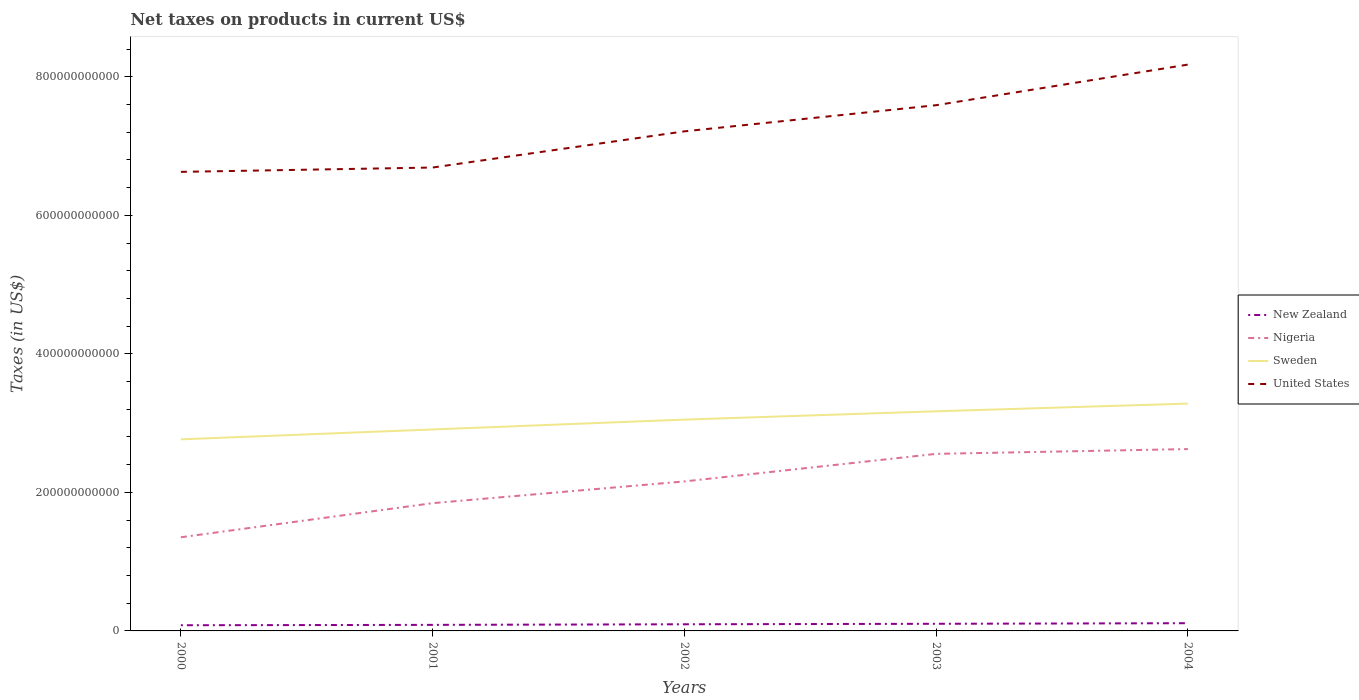Across all years, what is the maximum net taxes on products in New Zealand?
Provide a short and direct response. 8.20e+09. What is the total net taxes on products in Nigeria in the graph?
Ensure brevity in your answer.  -4.92e+1. What is the difference between the highest and the second highest net taxes on products in Nigeria?
Provide a succinct answer. 1.27e+11. What is the difference between the highest and the lowest net taxes on products in United States?
Offer a terse response. 2. How many years are there in the graph?
Provide a succinct answer. 5. What is the difference between two consecutive major ticks on the Y-axis?
Offer a terse response. 2.00e+11. Are the values on the major ticks of Y-axis written in scientific E-notation?
Your answer should be compact. No. Does the graph contain any zero values?
Provide a short and direct response. No. Does the graph contain grids?
Ensure brevity in your answer.  No. How are the legend labels stacked?
Provide a short and direct response. Vertical. What is the title of the graph?
Your answer should be very brief. Net taxes on products in current US$. Does "Andorra" appear as one of the legend labels in the graph?
Your answer should be compact. No. What is the label or title of the X-axis?
Give a very brief answer. Years. What is the label or title of the Y-axis?
Provide a succinct answer. Taxes (in US$). What is the Taxes (in US$) in New Zealand in 2000?
Offer a very short reply. 8.20e+09. What is the Taxes (in US$) of Nigeria in 2000?
Give a very brief answer. 1.35e+11. What is the Taxes (in US$) of Sweden in 2000?
Provide a short and direct response. 2.77e+11. What is the Taxes (in US$) in United States in 2000?
Provide a short and direct response. 6.63e+11. What is the Taxes (in US$) of New Zealand in 2001?
Keep it short and to the point. 8.74e+09. What is the Taxes (in US$) in Nigeria in 2001?
Provide a succinct answer. 1.84e+11. What is the Taxes (in US$) of Sweden in 2001?
Give a very brief answer. 2.91e+11. What is the Taxes (in US$) of United States in 2001?
Give a very brief answer. 6.69e+11. What is the Taxes (in US$) in New Zealand in 2002?
Your response must be concise. 9.59e+09. What is the Taxes (in US$) in Nigeria in 2002?
Offer a very short reply. 2.16e+11. What is the Taxes (in US$) of Sweden in 2002?
Keep it short and to the point. 3.05e+11. What is the Taxes (in US$) of United States in 2002?
Provide a succinct answer. 7.21e+11. What is the Taxes (in US$) of New Zealand in 2003?
Give a very brief answer. 1.03e+1. What is the Taxes (in US$) in Nigeria in 2003?
Make the answer very short. 2.56e+11. What is the Taxes (in US$) of Sweden in 2003?
Make the answer very short. 3.17e+11. What is the Taxes (in US$) in United States in 2003?
Make the answer very short. 7.59e+11. What is the Taxes (in US$) of New Zealand in 2004?
Ensure brevity in your answer.  1.11e+1. What is the Taxes (in US$) in Nigeria in 2004?
Ensure brevity in your answer.  2.63e+11. What is the Taxes (in US$) of Sweden in 2004?
Your answer should be compact. 3.28e+11. What is the Taxes (in US$) of United States in 2004?
Offer a terse response. 8.18e+11. Across all years, what is the maximum Taxes (in US$) in New Zealand?
Provide a succinct answer. 1.11e+1. Across all years, what is the maximum Taxes (in US$) of Nigeria?
Make the answer very short. 2.63e+11. Across all years, what is the maximum Taxes (in US$) in Sweden?
Offer a terse response. 3.28e+11. Across all years, what is the maximum Taxes (in US$) of United States?
Make the answer very short. 8.18e+11. Across all years, what is the minimum Taxes (in US$) of New Zealand?
Provide a short and direct response. 8.20e+09. Across all years, what is the minimum Taxes (in US$) in Nigeria?
Give a very brief answer. 1.35e+11. Across all years, what is the minimum Taxes (in US$) in Sweden?
Give a very brief answer. 2.77e+11. Across all years, what is the minimum Taxes (in US$) in United States?
Your answer should be compact. 6.63e+11. What is the total Taxes (in US$) of New Zealand in the graph?
Ensure brevity in your answer.  4.80e+1. What is the total Taxes (in US$) in Nigeria in the graph?
Provide a short and direct response. 1.05e+12. What is the total Taxes (in US$) in Sweden in the graph?
Your answer should be very brief. 1.52e+12. What is the total Taxes (in US$) in United States in the graph?
Ensure brevity in your answer.  3.63e+12. What is the difference between the Taxes (in US$) of New Zealand in 2000 and that in 2001?
Your answer should be compact. -5.36e+08. What is the difference between the Taxes (in US$) in Nigeria in 2000 and that in 2001?
Your answer should be very brief. -4.92e+1. What is the difference between the Taxes (in US$) of Sweden in 2000 and that in 2001?
Your response must be concise. -1.43e+1. What is the difference between the Taxes (in US$) of United States in 2000 and that in 2001?
Your answer should be very brief. -6.25e+09. What is the difference between the Taxes (in US$) in New Zealand in 2000 and that in 2002?
Provide a short and direct response. -1.39e+09. What is the difference between the Taxes (in US$) of Nigeria in 2000 and that in 2002?
Make the answer very short. -8.06e+1. What is the difference between the Taxes (in US$) of Sweden in 2000 and that in 2002?
Provide a succinct answer. -2.85e+1. What is the difference between the Taxes (in US$) of United States in 2000 and that in 2002?
Your answer should be compact. -5.85e+1. What is the difference between the Taxes (in US$) of New Zealand in 2000 and that in 2003?
Your answer should be compact. -2.09e+09. What is the difference between the Taxes (in US$) of Nigeria in 2000 and that in 2003?
Your answer should be compact. -1.20e+11. What is the difference between the Taxes (in US$) in Sweden in 2000 and that in 2003?
Your response must be concise. -4.05e+1. What is the difference between the Taxes (in US$) in United States in 2000 and that in 2003?
Your response must be concise. -9.62e+1. What is the difference between the Taxes (in US$) in New Zealand in 2000 and that in 2004?
Offer a very short reply. -2.94e+09. What is the difference between the Taxes (in US$) of Nigeria in 2000 and that in 2004?
Your answer should be very brief. -1.27e+11. What is the difference between the Taxes (in US$) in Sweden in 2000 and that in 2004?
Keep it short and to the point. -5.16e+1. What is the difference between the Taxes (in US$) of United States in 2000 and that in 2004?
Offer a very short reply. -1.55e+11. What is the difference between the Taxes (in US$) of New Zealand in 2001 and that in 2002?
Ensure brevity in your answer.  -8.53e+08. What is the difference between the Taxes (in US$) of Nigeria in 2001 and that in 2002?
Make the answer very short. -3.14e+1. What is the difference between the Taxes (in US$) of Sweden in 2001 and that in 2002?
Offer a very short reply. -1.42e+1. What is the difference between the Taxes (in US$) in United States in 2001 and that in 2002?
Make the answer very short. -5.22e+1. What is the difference between the Taxes (in US$) in New Zealand in 2001 and that in 2003?
Provide a succinct answer. -1.55e+09. What is the difference between the Taxes (in US$) in Nigeria in 2001 and that in 2003?
Your response must be concise. -7.12e+1. What is the difference between the Taxes (in US$) in Sweden in 2001 and that in 2003?
Provide a succinct answer. -2.62e+1. What is the difference between the Taxes (in US$) in United States in 2001 and that in 2003?
Provide a short and direct response. -9.00e+1. What is the difference between the Taxes (in US$) in New Zealand in 2001 and that in 2004?
Your answer should be very brief. -2.40e+09. What is the difference between the Taxes (in US$) in Nigeria in 2001 and that in 2004?
Keep it short and to the point. -7.81e+1. What is the difference between the Taxes (in US$) of Sweden in 2001 and that in 2004?
Your answer should be very brief. -3.73e+1. What is the difference between the Taxes (in US$) in United States in 2001 and that in 2004?
Your response must be concise. -1.49e+11. What is the difference between the Taxes (in US$) in New Zealand in 2002 and that in 2003?
Your response must be concise. -6.98e+08. What is the difference between the Taxes (in US$) in Nigeria in 2002 and that in 2003?
Ensure brevity in your answer.  -3.98e+1. What is the difference between the Taxes (in US$) of Sweden in 2002 and that in 2003?
Your answer should be very brief. -1.20e+1. What is the difference between the Taxes (in US$) of United States in 2002 and that in 2003?
Give a very brief answer. -3.77e+1. What is the difference between the Taxes (in US$) in New Zealand in 2002 and that in 2004?
Give a very brief answer. -1.55e+09. What is the difference between the Taxes (in US$) in Nigeria in 2002 and that in 2004?
Offer a terse response. -4.67e+1. What is the difference between the Taxes (in US$) of Sweden in 2002 and that in 2004?
Offer a very short reply. -2.31e+1. What is the difference between the Taxes (in US$) of United States in 2002 and that in 2004?
Make the answer very short. -9.63e+1. What is the difference between the Taxes (in US$) in New Zealand in 2003 and that in 2004?
Keep it short and to the point. -8.52e+08. What is the difference between the Taxes (in US$) in Nigeria in 2003 and that in 2004?
Make the answer very short. -6.92e+09. What is the difference between the Taxes (in US$) in Sweden in 2003 and that in 2004?
Your answer should be very brief. -1.11e+1. What is the difference between the Taxes (in US$) in United States in 2003 and that in 2004?
Give a very brief answer. -5.86e+1. What is the difference between the Taxes (in US$) in New Zealand in 2000 and the Taxes (in US$) in Nigeria in 2001?
Keep it short and to the point. -1.76e+11. What is the difference between the Taxes (in US$) in New Zealand in 2000 and the Taxes (in US$) in Sweden in 2001?
Offer a terse response. -2.83e+11. What is the difference between the Taxes (in US$) of New Zealand in 2000 and the Taxes (in US$) of United States in 2001?
Your response must be concise. -6.61e+11. What is the difference between the Taxes (in US$) in Nigeria in 2000 and the Taxes (in US$) in Sweden in 2001?
Provide a short and direct response. -1.56e+11. What is the difference between the Taxes (in US$) in Nigeria in 2000 and the Taxes (in US$) in United States in 2001?
Provide a succinct answer. -5.34e+11. What is the difference between the Taxes (in US$) in Sweden in 2000 and the Taxes (in US$) in United States in 2001?
Your answer should be very brief. -3.92e+11. What is the difference between the Taxes (in US$) in New Zealand in 2000 and the Taxes (in US$) in Nigeria in 2002?
Your response must be concise. -2.08e+11. What is the difference between the Taxes (in US$) in New Zealand in 2000 and the Taxes (in US$) in Sweden in 2002?
Your answer should be very brief. -2.97e+11. What is the difference between the Taxes (in US$) of New Zealand in 2000 and the Taxes (in US$) of United States in 2002?
Ensure brevity in your answer.  -7.13e+11. What is the difference between the Taxes (in US$) in Nigeria in 2000 and the Taxes (in US$) in Sweden in 2002?
Ensure brevity in your answer.  -1.70e+11. What is the difference between the Taxes (in US$) in Nigeria in 2000 and the Taxes (in US$) in United States in 2002?
Give a very brief answer. -5.86e+11. What is the difference between the Taxes (in US$) of Sweden in 2000 and the Taxes (in US$) of United States in 2002?
Your answer should be compact. -4.45e+11. What is the difference between the Taxes (in US$) of New Zealand in 2000 and the Taxes (in US$) of Nigeria in 2003?
Provide a succinct answer. -2.47e+11. What is the difference between the Taxes (in US$) of New Zealand in 2000 and the Taxes (in US$) of Sweden in 2003?
Your response must be concise. -3.09e+11. What is the difference between the Taxes (in US$) of New Zealand in 2000 and the Taxes (in US$) of United States in 2003?
Your answer should be very brief. -7.51e+11. What is the difference between the Taxes (in US$) of Nigeria in 2000 and the Taxes (in US$) of Sweden in 2003?
Provide a succinct answer. -1.82e+11. What is the difference between the Taxes (in US$) of Nigeria in 2000 and the Taxes (in US$) of United States in 2003?
Make the answer very short. -6.24e+11. What is the difference between the Taxes (in US$) of Sweden in 2000 and the Taxes (in US$) of United States in 2003?
Offer a very short reply. -4.82e+11. What is the difference between the Taxes (in US$) in New Zealand in 2000 and the Taxes (in US$) in Nigeria in 2004?
Ensure brevity in your answer.  -2.54e+11. What is the difference between the Taxes (in US$) in New Zealand in 2000 and the Taxes (in US$) in Sweden in 2004?
Your answer should be compact. -3.20e+11. What is the difference between the Taxes (in US$) in New Zealand in 2000 and the Taxes (in US$) in United States in 2004?
Your response must be concise. -8.09e+11. What is the difference between the Taxes (in US$) of Nigeria in 2000 and the Taxes (in US$) of Sweden in 2004?
Make the answer very short. -1.93e+11. What is the difference between the Taxes (in US$) in Nigeria in 2000 and the Taxes (in US$) in United States in 2004?
Provide a succinct answer. -6.82e+11. What is the difference between the Taxes (in US$) in Sweden in 2000 and the Taxes (in US$) in United States in 2004?
Keep it short and to the point. -5.41e+11. What is the difference between the Taxes (in US$) in New Zealand in 2001 and the Taxes (in US$) in Nigeria in 2002?
Offer a terse response. -2.07e+11. What is the difference between the Taxes (in US$) in New Zealand in 2001 and the Taxes (in US$) in Sweden in 2002?
Your response must be concise. -2.96e+11. What is the difference between the Taxes (in US$) of New Zealand in 2001 and the Taxes (in US$) of United States in 2002?
Provide a succinct answer. -7.12e+11. What is the difference between the Taxes (in US$) of Nigeria in 2001 and the Taxes (in US$) of Sweden in 2002?
Your answer should be very brief. -1.21e+11. What is the difference between the Taxes (in US$) of Nigeria in 2001 and the Taxes (in US$) of United States in 2002?
Make the answer very short. -5.37e+11. What is the difference between the Taxes (in US$) in Sweden in 2001 and the Taxes (in US$) in United States in 2002?
Ensure brevity in your answer.  -4.30e+11. What is the difference between the Taxes (in US$) of New Zealand in 2001 and the Taxes (in US$) of Nigeria in 2003?
Ensure brevity in your answer.  -2.47e+11. What is the difference between the Taxes (in US$) of New Zealand in 2001 and the Taxes (in US$) of Sweden in 2003?
Your answer should be compact. -3.08e+11. What is the difference between the Taxes (in US$) of New Zealand in 2001 and the Taxes (in US$) of United States in 2003?
Make the answer very short. -7.50e+11. What is the difference between the Taxes (in US$) of Nigeria in 2001 and the Taxes (in US$) of Sweden in 2003?
Your response must be concise. -1.33e+11. What is the difference between the Taxes (in US$) in Nigeria in 2001 and the Taxes (in US$) in United States in 2003?
Provide a succinct answer. -5.75e+11. What is the difference between the Taxes (in US$) of Sweden in 2001 and the Taxes (in US$) of United States in 2003?
Make the answer very short. -4.68e+11. What is the difference between the Taxes (in US$) in New Zealand in 2001 and the Taxes (in US$) in Nigeria in 2004?
Provide a short and direct response. -2.54e+11. What is the difference between the Taxes (in US$) in New Zealand in 2001 and the Taxes (in US$) in Sweden in 2004?
Provide a succinct answer. -3.19e+11. What is the difference between the Taxes (in US$) in New Zealand in 2001 and the Taxes (in US$) in United States in 2004?
Your response must be concise. -8.09e+11. What is the difference between the Taxes (in US$) of Nigeria in 2001 and the Taxes (in US$) of Sweden in 2004?
Your answer should be very brief. -1.44e+11. What is the difference between the Taxes (in US$) of Nigeria in 2001 and the Taxes (in US$) of United States in 2004?
Make the answer very short. -6.33e+11. What is the difference between the Taxes (in US$) in Sweden in 2001 and the Taxes (in US$) in United States in 2004?
Give a very brief answer. -5.27e+11. What is the difference between the Taxes (in US$) of New Zealand in 2002 and the Taxes (in US$) of Nigeria in 2003?
Make the answer very short. -2.46e+11. What is the difference between the Taxes (in US$) in New Zealand in 2002 and the Taxes (in US$) in Sweden in 2003?
Ensure brevity in your answer.  -3.07e+11. What is the difference between the Taxes (in US$) of New Zealand in 2002 and the Taxes (in US$) of United States in 2003?
Offer a very short reply. -7.49e+11. What is the difference between the Taxes (in US$) in Nigeria in 2002 and the Taxes (in US$) in Sweden in 2003?
Make the answer very short. -1.01e+11. What is the difference between the Taxes (in US$) of Nigeria in 2002 and the Taxes (in US$) of United States in 2003?
Offer a very short reply. -5.43e+11. What is the difference between the Taxes (in US$) of Sweden in 2002 and the Taxes (in US$) of United States in 2003?
Provide a succinct answer. -4.54e+11. What is the difference between the Taxes (in US$) in New Zealand in 2002 and the Taxes (in US$) in Nigeria in 2004?
Offer a very short reply. -2.53e+11. What is the difference between the Taxes (in US$) of New Zealand in 2002 and the Taxes (in US$) of Sweden in 2004?
Provide a succinct answer. -3.19e+11. What is the difference between the Taxes (in US$) of New Zealand in 2002 and the Taxes (in US$) of United States in 2004?
Provide a short and direct response. -8.08e+11. What is the difference between the Taxes (in US$) of Nigeria in 2002 and the Taxes (in US$) of Sweden in 2004?
Offer a very short reply. -1.12e+11. What is the difference between the Taxes (in US$) of Nigeria in 2002 and the Taxes (in US$) of United States in 2004?
Ensure brevity in your answer.  -6.02e+11. What is the difference between the Taxes (in US$) in Sweden in 2002 and the Taxes (in US$) in United States in 2004?
Keep it short and to the point. -5.12e+11. What is the difference between the Taxes (in US$) in New Zealand in 2003 and the Taxes (in US$) in Nigeria in 2004?
Give a very brief answer. -2.52e+11. What is the difference between the Taxes (in US$) of New Zealand in 2003 and the Taxes (in US$) of Sweden in 2004?
Ensure brevity in your answer.  -3.18e+11. What is the difference between the Taxes (in US$) of New Zealand in 2003 and the Taxes (in US$) of United States in 2004?
Ensure brevity in your answer.  -8.07e+11. What is the difference between the Taxes (in US$) of Nigeria in 2003 and the Taxes (in US$) of Sweden in 2004?
Offer a terse response. -7.25e+1. What is the difference between the Taxes (in US$) in Nigeria in 2003 and the Taxes (in US$) in United States in 2004?
Give a very brief answer. -5.62e+11. What is the difference between the Taxes (in US$) in Sweden in 2003 and the Taxes (in US$) in United States in 2004?
Offer a very short reply. -5.00e+11. What is the average Taxes (in US$) in New Zealand per year?
Ensure brevity in your answer.  9.59e+09. What is the average Taxes (in US$) in Nigeria per year?
Provide a short and direct response. 2.11e+11. What is the average Taxes (in US$) of Sweden per year?
Make the answer very short. 3.04e+11. What is the average Taxes (in US$) in United States per year?
Offer a very short reply. 7.26e+11. In the year 2000, what is the difference between the Taxes (in US$) of New Zealand and Taxes (in US$) of Nigeria?
Offer a terse response. -1.27e+11. In the year 2000, what is the difference between the Taxes (in US$) of New Zealand and Taxes (in US$) of Sweden?
Offer a very short reply. -2.68e+11. In the year 2000, what is the difference between the Taxes (in US$) in New Zealand and Taxes (in US$) in United States?
Provide a succinct answer. -6.55e+11. In the year 2000, what is the difference between the Taxes (in US$) of Nigeria and Taxes (in US$) of Sweden?
Keep it short and to the point. -1.41e+11. In the year 2000, what is the difference between the Taxes (in US$) in Nigeria and Taxes (in US$) in United States?
Keep it short and to the point. -5.28e+11. In the year 2000, what is the difference between the Taxes (in US$) in Sweden and Taxes (in US$) in United States?
Offer a very short reply. -3.86e+11. In the year 2001, what is the difference between the Taxes (in US$) of New Zealand and Taxes (in US$) of Nigeria?
Ensure brevity in your answer.  -1.76e+11. In the year 2001, what is the difference between the Taxes (in US$) of New Zealand and Taxes (in US$) of Sweden?
Your response must be concise. -2.82e+11. In the year 2001, what is the difference between the Taxes (in US$) of New Zealand and Taxes (in US$) of United States?
Offer a terse response. -6.60e+11. In the year 2001, what is the difference between the Taxes (in US$) in Nigeria and Taxes (in US$) in Sweden?
Offer a very short reply. -1.06e+11. In the year 2001, what is the difference between the Taxes (in US$) in Nigeria and Taxes (in US$) in United States?
Provide a succinct answer. -4.85e+11. In the year 2001, what is the difference between the Taxes (in US$) of Sweden and Taxes (in US$) of United States?
Offer a very short reply. -3.78e+11. In the year 2002, what is the difference between the Taxes (in US$) in New Zealand and Taxes (in US$) in Nigeria?
Ensure brevity in your answer.  -2.06e+11. In the year 2002, what is the difference between the Taxes (in US$) of New Zealand and Taxes (in US$) of Sweden?
Ensure brevity in your answer.  -2.95e+11. In the year 2002, what is the difference between the Taxes (in US$) of New Zealand and Taxes (in US$) of United States?
Keep it short and to the point. -7.12e+11. In the year 2002, what is the difference between the Taxes (in US$) in Nigeria and Taxes (in US$) in Sweden?
Provide a succinct answer. -8.93e+1. In the year 2002, what is the difference between the Taxes (in US$) of Nigeria and Taxes (in US$) of United States?
Give a very brief answer. -5.05e+11. In the year 2002, what is the difference between the Taxes (in US$) in Sweden and Taxes (in US$) in United States?
Your answer should be very brief. -4.16e+11. In the year 2003, what is the difference between the Taxes (in US$) in New Zealand and Taxes (in US$) in Nigeria?
Your response must be concise. -2.45e+11. In the year 2003, what is the difference between the Taxes (in US$) in New Zealand and Taxes (in US$) in Sweden?
Your answer should be very brief. -3.07e+11. In the year 2003, what is the difference between the Taxes (in US$) in New Zealand and Taxes (in US$) in United States?
Your answer should be compact. -7.49e+11. In the year 2003, what is the difference between the Taxes (in US$) of Nigeria and Taxes (in US$) of Sweden?
Provide a succinct answer. -6.15e+1. In the year 2003, what is the difference between the Taxes (in US$) of Nigeria and Taxes (in US$) of United States?
Your response must be concise. -5.03e+11. In the year 2003, what is the difference between the Taxes (in US$) of Sweden and Taxes (in US$) of United States?
Provide a succinct answer. -4.42e+11. In the year 2004, what is the difference between the Taxes (in US$) in New Zealand and Taxes (in US$) in Nigeria?
Give a very brief answer. -2.51e+11. In the year 2004, what is the difference between the Taxes (in US$) of New Zealand and Taxes (in US$) of Sweden?
Offer a very short reply. -3.17e+11. In the year 2004, what is the difference between the Taxes (in US$) in New Zealand and Taxes (in US$) in United States?
Give a very brief answer. -8.06e+11. In the year 2004, what is the difference between the Taxes (in US$) of Nigeria and Taxes (in US$) of Sweden?
Provide a succinct answer. -6.56e+1. In the year 2004, what is the difference between the Taxes (in US$) of Nigeria and Taxes (in US$) of United States?
Your answer should be very brief. -5.55e+11. In the year 2004, what is the difference between the Taxes (in US$) in Sweden and Taxes (in US$) in United States?
Your answer should be very brief. -4.89e+11. What is the ratio of the Taxes (in US$) in New Zealand in 2000 to that in 2001?
Your response must be concise. 0.94. What is the ratio of the Taxes (in US$) of Nigeria in 2000 to that in 2001?
Give a very brief answer. 0.73. What is the ratio of the Taxes (in US$) in Sweden in 2000 to that in 2001?
Your response must be concise. 0.95. What is the ratio of the Taxes (in US$) in United States in 2000 to that in 2001?
Make the answer very short. 0.99. What is the ratio of the Taxes (in US$) in New Zealand in 2000 to that in 2002?
Provide a succinct answer. 0.86. What is the ratio of the Taxes (in US$) in Nigeria in 2000 to that in 2002?
Give a very brief answer. 0.63. What is the ratio of the Taxes (in US$) in Sweden in 2000 to that in 2002?
Provide a succinct answer. 0.91. What is the ratio of the Taxes (in US$) in United States in 2000 to that in 2002?
Make the answer very short. 0.92. What is the ratio of the Taxes (in US$) of New Zealand in 2000 to that in 2003?
Your response must be concise. 0.8. What is the ratio of the Taxes (in US$) in Nigeria in 2000 to that in 2003?
Ensure brevity in your answer.  0.53. What is the ratio of the Taxes (in US$) in Sweden in 2000 to that in 2003?
Make the answer very short. 0.87. What is the ratio of the Taxes (in US$) in United States in 2000 to that in 2003?
Offer a very short reply. 0.87. What is the ratio of the Taxes (in US$) of New Zealand in 2000 to that in 2004?
Give a very brief answer. 0.74. What is the ratio of the Taxes (in US$) of Nigeria in 2000 to that in 2004?
Provide a short and direct response. 0.52. What is the ratio of the Taxes (in US$) of Sweden in 2000 to that in 2004?
Give a very brief answer. 0.84. What is the ratio of the Taxes (in US$) of United States in 2000 to that in 2004?
Offer a very short reply. 0.81. What is the ratio of the Taxes (in US$) of New Zealand in 2001 to that in 2002?
Keep it short and to the point. 0.91. What is the ratio of the Taxes (in US$) of Nigeria in 2001 to that in 2002?
Keep it short and to the point. 0.85. What is the ratio of the Taxes (in US$) of Sweden in 2001 to that in 2002?
Make the answer very short. 0.95. What is the ratio of the Taxes (in US$) of United States in 2001 to that in 2002?
Give a very brief answer. 0.93. What is the ratio of the Taxes (in US$) in New Zealand in 2001 to that in 2003?
Your answer should be compact. 0.85. What is the ratio of the Taxes (in US$) in Nigeria in 2001 to that in 2003?
Make the answer very short. 0.72. What is the ratio of the Taxes (in US$) in Sweden in 2001 to that in 2003?
Provide a short and direct response. 0.92. What is the ratio of the Taxes (in US$) of United States in 2001 to that in 2003?
Ensure brevity in your answer.  0.88. What is the ratio of the Taxes (in US$) of New Zealand in 2001 to that in 2004?
Your response must be concise. 0.78. What is the ratio of the Taxes (in US$) in Nigeria in 2001 to that in 2004?
Offer a terse response. 0.7. What is the ratio of the Taxes (in US$) in Sweden in 2001 to that in 2004?
Your response must be concise. 0.89. What is the ratio of the Taxes (in US$) of United States in 2001 to that in 2004?
Make the answer very short. 0.82. What is the ratio of the Taxes (in US$) in New Zealand in 2002 to that in 2003?
Make the answer very short. 0.93. What is the ratio of the Taxes (in US$) of Nigeria in 2002 to that in 2003?
Make the answer very short. 0.84. What is the ratio of the Taxes (in US$) in Sweden in 2002 to that in 2003?
Provide a short and direct response. 0.96. What is the ratio of the Taxes (in US$) in United States in 2002 to that in 2003?
Provide a short and direct response. 0.95. What is the ratio of the Taxes (in US$) of New Zealand in 2002 to that in 2004?
Offer a terse response. 0.86. What is the ratio of the Taxes (in US$) of Nigeria in 2002 to that in 2004?
Your response must be concise. 0.82. What is the ratio of the Taxes (in US$) of Sweden in 2002 to that in 2004?
Provide a short and direct response. 0.93. What is the ratio of the Taxes (in US$) of United States in 2002 to that in 2004?
Your answer should be compact. 0.88. What is the ratio of the Taxes (in US$) of New Zealand in 2003 to that in 2004?
Your answer should be very brief. 0.92. What is the ratio of the Taxes (in US$) in Nigeria in 2003 to that in 2004?
Make the answer very short. 0.97. What is the ratio of the Taxes (in US$) in Sweden in 2003 to that in 2004?
Offer a terse response. 0.97. What is the ratio of the Taxes (in US$) in United States in 2003 to that in 2004?
Make the answer very short. 0.93. What is the difference between the highest and the second highest Taxes (in US$) in New Zealand?
Offer a terse response. 8.52e+08. What is the difference between the highest and the second highest Taxes (in US$) of Nigeria?
Ensure brevity in your answer.  6.92e+09. What is the difference between the highest and the second highest Taxes (in US$) of Sweden?
Ensure brevity in your answer.  1.11e+1. What is the difference between the highest and the second highest Taxes (in US$) in United States?
Offer a very short reply. 5.86e+1. What is the difference between the highest and the lowest Taxes (in US$) of New Zealand?
Ensure brevity in your answer.  2.94e+09. What is the difference between the highest and the lowest Taxes (in US$) in Nigeria?
Provide a short and direct response. 1.27e+11. What is the difference between the highest and the lowest Taxes (in US$) in Sweden?
Your response must be concise. 5.16e+1. What is the difference between the highest and the lowest Taxes (in US$) of United States?
Your answer should be very brief. 1.55e+11. 